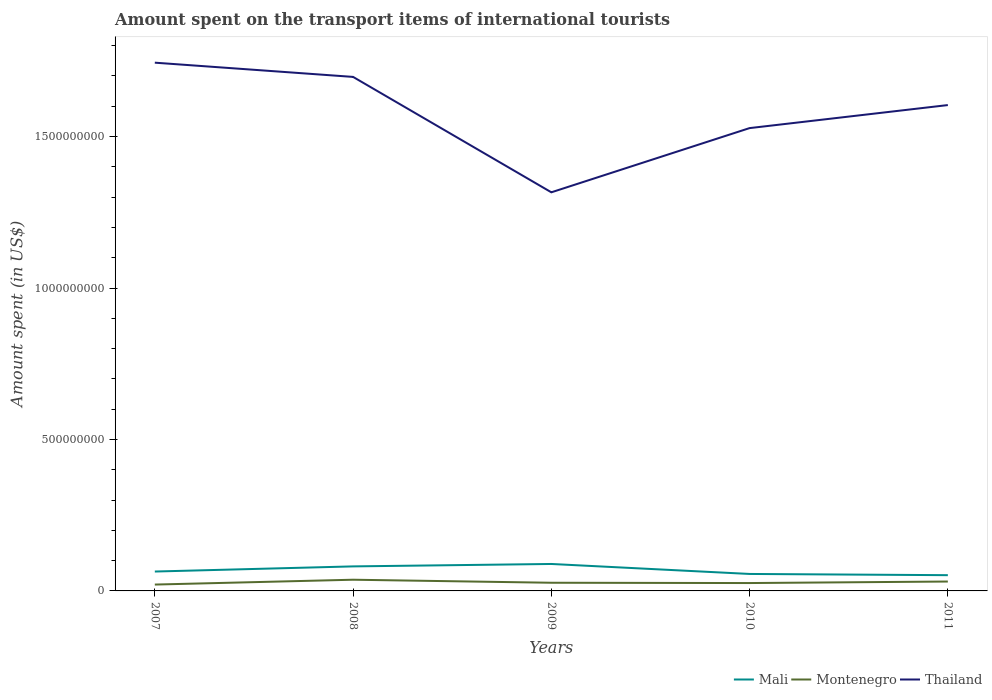How many different coloured lines are there?
Ensure brevity in your answer.  3. Does the line corresponding to Montenegro intersect with the line corresponding to Thailand?
Make the answer very short. No. Across all years, what is the maximum amount spent on the transport items of international tourists in Mali?
Keep it short and to the point. 5.20e+07. In which year was the amount spent on the transport items of international tourists in Thailand maximum?
Give a very brief answer. 2009. What is the total amount spent on the transport items of international tourists in Thailand in the graph?
Your answer should be very brief. 9.30e+07. What is the difference between the highest and the second highest amount spent on the transport items of international tourists in Montenegro?
Provide a succinct answer. 1.60e+07. What is the difference between the highest and the lowest amount spent on the transport items of international tourists in Montenegro?
Offer a very short reply. 2. How many lines are there?
Offer a terse response. 3. Does the graph contain any zero values?
Offer a terse response. No. Does the graph contain grids?
Make the answer very short. No. Where does the legend appear in the graph?
Keep it short and to the point. Bottom right. How many legend labels are there?
Offer a terse response. 3. What is the title of the graph?
Your response must be concise. Amount spent on the transport items of international tourists. What is the label or title of the Y-axis?
Your answer should be compact. Amount spent (in US$). What is the Amount spent (in US$) of Mali in 2007?
Keep it short and to the point. 6.40e+07. What is the Amount spent (in US$) in Montenegro in 2007?
Make the answer very short. 2.10e+07. What is the Amount spent (in US$) of Thailand in 2007?
Make the answer very short. 1.74e+09. What is the Amount spent (in US$) in Mali in 2008?
Give a very brief answer. 8.10e+07. What is the Amount spent (in US$) of Montenegro in 2008?
Give a very brief answer. 3.70e+07. What is the Amount spent (in US$) in Thailand in 2008?
Offer a very short reply. 1.70e+09. What is the Amount spent (in US$) in Mali in 2009?
Keep it short and to the point. 8.90e+07. What is the Amount spent (in US$) in Montenegro in 2009?
Offer a very short reply. 2.70e+07. What is the Amount spent (in US$) in Thailand in 2009?
Provide a short and direct response. 1.32e+09. What is the Amount spent (in US$) in Mali in 2010?
Your answer should be compact. 5.60e+07. What is the Amount spent (in US$) in Montenegro in 2010?
Your response must be concise. 2.60e+07. What is the Amount spent (in US$) of Thailand in 2010?
Your response must be concise. 1.53e+09. What is the Amount spent (in US$) in Mali in 2011?
Make the answer very short. 5.20e+07. What is the Amount spent (in US$) of Montenegro in 2011?
Your answer should be compact. 3.10e+07. What is the Amount spent (in US$) in Thailand in 2011?
Ensure brevity in your answer.  1.60e+09. Across all years, what is the maximum Amount spent (in US$) of Mali?
Provide a short and direct response. 8.90e+07. Across all years, what is the maximum Amount spent (in US$) in Montenegro?
Provide a short and direct response. 3.70e+07. Across all years, what is the maximum Amount spent (in US$) in Thailand?
Give a very brief answer. 1.74e+09. Across all years, what is the minimum Amount spent (in US$) of Mali?
Your response must be concise. 5.20e+07. Across all years, what is the minimum Amount spent (in US$) of Montenegro?
Provide a succinct answer. 2.10e+07. Across all years, what is the minimum Amount spent (in US$) of Thailand?
Offer a terse response. 1.32e+09. What is the total Amount spent (in US$) of Mali in the graph?
Your answer should be very brief. 3.42e+08. What is the total Amount spent (in US$) in Montenegro in the graph?
Give a very brief answer. 1.42e+08. What is the total Amount spent (in US$) of Thailand in the graph?
Make the answer very short. 7.89e+09. What is the difference between the Amount spent (in US$) of Mali in 2007 and that in 2008?
Make the answer very short. -1.70e+07. What is the difference between the Amount spent (in US$) of Montenegro in 2007 and that in 2008?
Keep it short and to the point. -1.60e+07. What is the difference between the Amount spent (in US$) of Thailand in 2007 and that in 2008?
Offer a terse response. 4.70e+07. What is the difference between the Amount spent (in US$) of Mali in 2007 and that in 2009?
Your answer should be very brief. -2.50e+07. What is the difference between the Amount spent (in US$) of Montenegro in 2007 and that in 2009?
Provide a short and direct response. -6.00e+06. What is the difference between the Amount spent (in US$) of Thailand in 2007 and that in 2009?
Your answer should be compact. 4.28e+08. What is the difference between the Amount spent (in US$) in Montenegro in 2007 and that in 2010?
Your response must be concise. -5.00e+06. What is the difference between the Amount spent (in US$) in Thailand in 2007 and that in 2010?
Offer a terse response. 2.16e+08. What is the difference between the Amount spent (in US$) of Mali in 2007 and that in 2011?
Your response must be concise. 1.20e+07. What is the difference between the Amount spent (in US$) in Montenegro in 2007 and that in 2011?
Your response must be concise. -1.00e+07. What is the difference between the Amount spent (in US$) of Thailand in 2007 and that in 2011?
Provide a short and direct response. 1.40e+08. What is the difference between the Amount spent (in US$) in Mali in 2008 and that in 2009?
Give a very brief answer. -8.00e+06. What is the difference between the Amount spent (in US$) of Montenegro in 2008 and that in 2009?
Provide a short and direct response. 1.00e+07. What is the difference between the Amount spent (in US$) in Thailand in 2008 and that in 2009?
Offer a very short reply. 3.81e+08. What is the difference between the Amount spent (in US$) in Mali in 2008 and that in 2010?
Your answer should be compact. 2.50e+07. What is the difference between the Amount spent (in US$) in Montenegro in 2008 and that in 2010?
Make the answer very short. 1.10e+07. What is the difference between the Amount spent (in US$) of Thailand in 2008 and that in 2010?
Provide a short and direct response. 1.69e+08. What is the difference between the Amount spent (in US$) in Mali in 2008 and that in 2011?
Ensure brevity in your answer.  2.90e+07. What is the difference between the Amount spent (in US$) in Thailand in 2008 and that in 2011?
Make the answer very short. 9.30e+07. What is the difference between the Amount spent (in US$) of Mali in 2009 and that in 2010?
Provide a short and direct response. 3.30e+07. What is the difference between the Amount spent (in US$) in Thailand in 2009 and that in 2010?
Offer a very short reply. -2.12e+08. What is the difference between the Amount spent (in US$) in Mali in 2009 and that in 2011?
Offer a very short reply. 3.70e+07. What is the difference between the Amount spent (in US$) of Thailand in 2009 and that in 2011?
Offer a terse response. -2.88e+08. What is the difference between the Amount spent (in US$) in Mali in 2010 and that in 2011?
Provide a succinct answer. 4.00e+06. What is the difference between the Amount spent (in US$) of Montenegro in 2010 and that in 2011?
Ensure brevity in your answer.  -5.00e+06. What is the difference between the Amount spent (in US$) of Thailand in 2010 and that in 2011?
Offer a very short reply. -7.60e+07. What is the difference between the Amount spent (in US$) in Mali in 2007 and the Amount spent (in US$) in Montenegro in 2008?
Offer a terse response. 2.70e+07. What is the difference between the Amount spent (in US$) in Mali in 2007 and the Amount spent (in US$) in Thailand in 2008?
Give a very brief answer. -1.63e+09. What is the difference between the Amount spent (in US$) of Montenegro in 2007 and the Amount spent (in US$) of Thailand in 2008?
Your answer should be compact. -1.68e+09. What is the difference between the Amount spent (in US$) in Mali in 2007 and the Amount spent (in US$) in Montenegro in 2009?
Offer a very short reply. 3.70e+07. What is the difference between the Amount spent (in US$) in Mali in 2007 and the Amount spent (in US$) in Thailand in 2009?
Your answer should be very brief. -1.25e+09. What is the difference between the Amount spent (in US$) of Montenegro in 2007 and the Amount spent (in US$) of Thailand in 2009?
Your answer should be compact. -1.30e+09. What is the difference between the Amount spent (in US$) in Mali in 2007 and the Amount spent (in US$) in Montenegro in 2010?
Make the answer very short. 3.80e+07. What is the difference between the Amount spent (in US$) in Mali in 2007 and the Amount spent (in US$) in Thailand in 2010?
Offer a very short reply. -1.46e+09. What is the difference between the Amount spent (in US$) of Montenegro in 2007 and the Amount spent (in US$) of Thailand in 2010?
Ensure brevity in your answer.  -1.51e+09. What is the difference between the Amount spent (in US$) in Mali in 2007 and the Amount spent (in US$) in Montenegro in 2011?
Your response must be concise. 3.30e+07. What is the difference between the Amount spent (in US$) in Mali in 2007 and the Amount spent (in US$) in Thailand in 2011?
Offer a terse response. -1.54e+09. What is the difference between the Amount spent (in US$) in Montenegro in 2007 and the Amount spent (in US$) in Thailand in 2011?
Offer a very short reply. -1.58e+09. What is the difference between the Amount spent (in US$) of Mali in 2008 and the Amount spent (in US$) of Montenegro in 2009?
Your answer should be compact. 5.40e+07. What is the difference between the Amount spent (in US$) in Mali in 2008 and the Amount spent (in US$) in Thailand in 2009?
Offer a terse response. -1.24e+09. What is the difference between the Amount spent (in US$) of Montenegro in 2008 and the Amount spent (in US$) of Thailand in 2009?
Provide a short and direct response. -1.28e+09. What is the difference between the Amount spent (in US$) of Mali in 2008 and the Amount spent (in US$) of Montenegro in 2010?
Ensure brevity in your answer.  5.50e+07. What is the difference between the Amount spent (in US$) of Mali in 2008 and the Amount spent (in US$) of Thailand in 2010?
Your answer should be compact. -1.45e+09. What is the difference between the Amount spent (in US$) in Montenegro in 2008 and the Amount spent (in US$) in Thailand in 2010?
Provide a short and direct response. -1.49e+09. What is the difference between the Amount spent (in US$) in Mali in 2008 and the Amount spent (in US$) in Montenegro in 2011?
Give a very brief answer. 5.00e+07. What is the difference between the Amount spent (in US$) in Mali in 2008 and the Amount spent (in US$) in Thailand in 2011?
Your answer should be very brief. -1.52e+09. What is the difference between the Amount spent (in US$) in Montenegro in 2008 and the Amount spent (in US$) in Thailand in 2011?
Provide a short and direct response. -1.57e+09. What is the difference between the Amount spent (in US$) in Mali in 2009 and the Amount spent (in US$) in Montenegro in 2010?
Give a very brief answer. 6.30e+07. What is the difference between the Amount spent (in US$) of Mali in 2009 and the Amount spent (in US$) of Thailand in 2010?
Provide a short and direct response. -1.44e+09. What is the difference between the Amount spent (in US$) in Montenegro in 2009 and the Amount spent (in US$) in Thailand in 2010?
Your answer should be compact. -1.50e+09. What is the difference between the Amount spent (in US$) in Mali in 2009 and the Amount spent (in US$) in Montenegro in 2011?
Ensure brevity in your answer.  5.80e+07. What is the difference between the Amount spent (in US$) in Mali in 2009 and the Amount spent (in US$) in Thailand in 2011?
Your response must be concise. -1.52e+09. What is the difference between the Amount spent (in US$) in Montenegro in 2009 and the Amount spent (in US$) in Thailand in 2011?
Your answer should be very brief. -1.58e+09. What is the difference between the Amount spent (in US$) in Mali in 2010 and the Amount spent (in US$) in Montenegro in 2011?
Offer a very short reply. 2.50e+07. What is the difference between the Amount spent (in US$) in Mali in 2010 and the Amount spent (in US$) in Thailand in 2011?
Your answer should be compact. -1.55e+09. What is the difference between the Amount spent (in US$) in Montenegro in 2010 and the Amount spent (in US$) in Thailand in 2011?
Your response must be concise. -1.58e+09. What is the average Amount spent (in US$) of Mali per year?
Make the answer very short. 6.84e+07. What is the average Amount spent (in US$) of Montenegro per year?
Provide a short and direct response. 2.84e+07. What is the average Amount spent (in US$) in Thailand per year?
Keep it short and to the point. 1.58e+09. In the year 2007, what is the difference between the Amount spent (in US$) of Mali and Amount spent (in US$) of Montenegro?
Provide a succinct answer. 4.30e+07. In the year 2007, what is the difference between the Amount spent (in US$) in Mali and Amount spent (in US$) in Thailand?
Offer a terse response. -1.68e+09. In the year 2007, what is the difference between the Amount spent (in US$) in Montenegro and Amount spent (in US$) in Thailand?
Your answer should be compact. -1.72e+09. In the year 2008, what is the difference between the Amount spent (in US$) in Mali and Amount spent (in US$) in Montenegro?
Keep it short and to the point. 4.40e+07. In the year 2008, what is the difference between the Amount spent (in US$) of Mali and Amount spent (in US$) of Thailand?
Ensure brevity in your answer.  -1.62e+09. In the year 2008, what is the difference between the Amount spent (in US$) of Montenegro and Amount spent (in US$) of Thailand?
Your answer should be compact. -1.66e+09. In the year 2009, what is the difference between the Amount spent (in US$) of Mali and Amount spent (in US$) of Montenegro?
Keep it short and to the point. 6.20e+07. In the year 2009, what is the difference between the Amount spent (in US$) in Mali and Amount spent (in US$) in Thailand?
Provide a short and direct response. -1.23e+09. In the year 2009, what is the difference between the Amount spent (in US$) in Montenegro and Amount spent (in US$) in Thailand?
Your answer should be very brief. -1.29e+09. In the year 2010, what is the difference between the Amount spent (in US$) of Mali and Amount spent (in US$) of Montenegro?
Provide a succinct answer. 3.00e+07. In the year 2010, what is the difference between the Amount spent (in US$) of Mali and Amount spent (in US$) of Thailand?
Your answer should be compact. -1.47e+09. In the year 2010, what is the difference between the Amount spent (in US$) in Montenegro and Amount spent (in US$) in Thailand?
Ensure brevity in your answer.  -1.50e+09. In the year 2011, what is the difference between the Amount spent (in US$) of Mali and Amount spent (in US$) of Montenegro?
Offer a very short reply. 2.10e+07. In the year 2011, what is the difference between the Amount spent (in US$) of Mali and Amount spent (in US$) of Thailand?
Offer a very short reply. -1.55e+09. In the year 2011, what is the difference between the Amount spent (in US$) of Montenegro and Amount spent (in US$) of Thailand?
Ensure brevity in your answer.  -1.57e+09. What is the ratio of the Amount spent (in US$) in Mali in 2007 to that in 2008?
Your response must be concise. 0.79. What is the ratio of the Amount spent (in US$) in Montenegro in 2007 to that in 2008?
Your answer should be compact. 0.57. What is the ratio of the Amount spent (in US$) in Thailand in 2007 to that in 2008?
Keep it short and to the point. 1.03. What is the ratio of the Amount spent (in US$) in Mali in 2007 to that in 2009?
Make the answer very short. 0.72. What is the ratio of the Amount spent (in US$) of Montenegro in 2007 to that in 2009?
Give a very brief answer. 0.78. What is the ratio of the Amount spent (in US$) of Thailand in 2007 to that in 2009?
Give a very brief answer. 1.33. What is the ratio of the Amount spent (in US$) in Mali in 2007 to that in 2010?
Give a very brief answer. 1.14. What is the ratio of the Amount spent (in US$) in Montenegro in 2007 to that in 2010?
Make the answer very short. 0.81. What is the ratio of the Amount spent (in US$) in Thailand in 2007 to that in 2010?
Offer a very short reply. 1.14. What is the ratio of the Amount spent (in US$) in Mali in 2007 to that in 2011?
Provide a short and direct response. 1.23. What is the ratio of the Amount spent (in US$) in Montenegro in 2007 to that in 2011?
Your answer should be very brief. 0.68. What is the ratio of the Amount spent (in US$) of Thailand in 2007 to that in 2011?
Your answer should be compact. 1.09. What is the ratio of the Amount spent (in US$) of Mali in 2008 to that in 2009?
Offer a terse response. 0.91. What is the ratio of the Amount spent (in US$) in Montenegro in 2008 to that in 2009?
Give a very brief answer. 1.37. What is the ratio of the Amount spent (in US$) of Thailand in 2008 to that in 2009?
Provide a succinct answer. 1.29. What is the ratio of the Amount spent (in US$) of Mali in 2008 to that in 2010?
Keep it short and to the point. 1.45. What is the ratio of the Amount spent (in US$) in Montenegro in 2008 to that in 2010?
Provide a short and direct response. 1.42. What is the ratio of the Amount spent (in US$) in Thailand in 2008 to that in 2010?
Keep it short and to the point. 1.11. What is the ratio of the Amount spent (in US$) of Mali in 2008 to that in 2011?
Your response must be concise. 1.56. What is the ratio of the Amount spent (in US$) of Montenegro in 2008 to that in 2011?
Your answer should be very brief. 1.19. What is the ratio of the Amount spent (in US$) of Thailand in 2008 to that in 2011?
Ensure brevity in your answer.  1.06. What is the ratio of the Amount spent (in US$) of Mali in 2009 to that in 2010?
Give a very brief answer. 1.59. What is the ratio of the Amount spent (in US$) of Thailand in 2009 to that in 2010?
Provide a succinct answer. 0.86. What is the ratio of the Amount spent (in US$) in Mali in 2009 to that in 2011?
Your answer should be very brief. 1.71. What is the ratio of the Amount spent (in US$) in Montenegro in 2009 to that in 2011?
Make the answer very short. 0.87. What is the ratio of the Amount spent (in US$) in Thailand in 2009 to that in 2011?
Your answer should be very brief. 0.82. What is the ratio of the Amount spent (in US$) of Mali in 2010 to that in 2011?
Make the answer very short. 1.08. What is the ratio of the Amount spent (in US$) of Montenegro in 2010 to that in 2011?
Ensure brevity in your answer.  0.84. What is the ratio of the Amount spent (in US$) of Thailand in 2010 to that in 2011?
Give a very brief answer. 0.95. What is the difference between the highest and the second highest Amount spent (in US$) of Mali?
Offer a terse response. 8.00e+06. What is the difference between the highest and the second highest Amount spent (in US$) of Montenegro?
Keep it short and to the point. 6.00e+06. What is the difference between the highest and the second highest Amount spent (in US$) of Thailand?
Provide a succinct answer. 4.70e+07. What is the difference between the highest and the lowest Amount spent (in US$) in Mali?
Provide a short and direct response. 3.70e+07. What is the difference between the highest and the lowest Amount spent (in US$) of Montenegro?
Offer a very short reply. 1.60e+07. What is the difference between the highest and the lowest Amount spent (in US$) of Thailand?
Provide a short and direct response. 4.28e+08. 